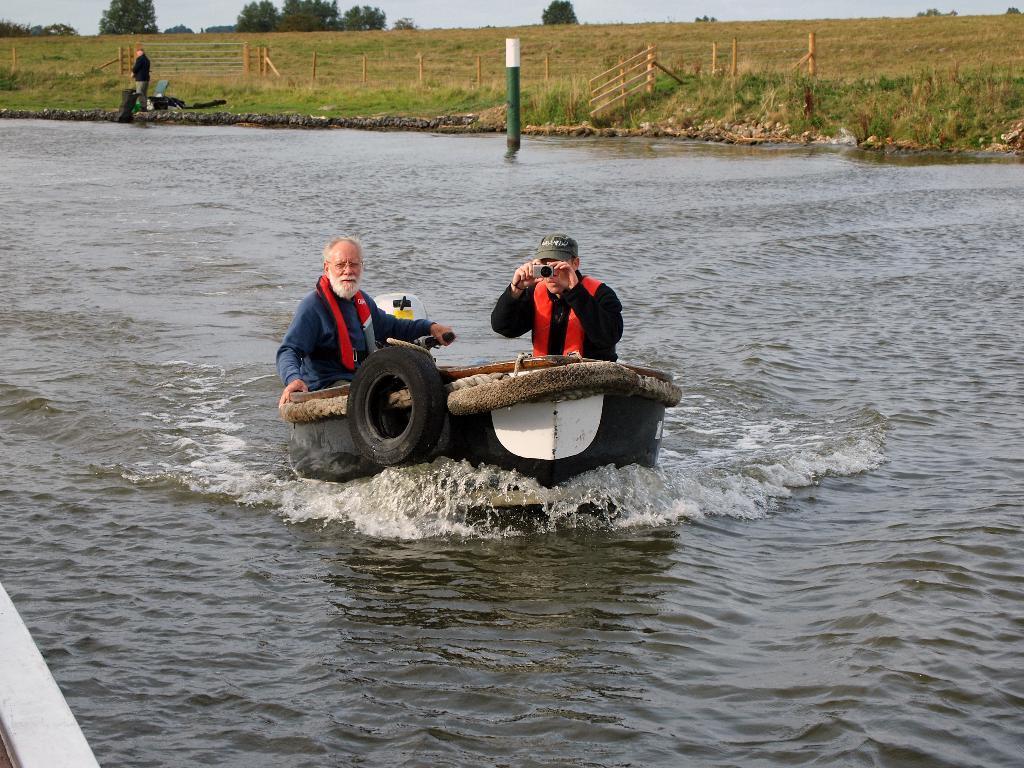Describe this image in one or two sentences. In this image there are two people sitting on the boat, which is on the river, one of them is holding an object. In the background there is a person standing on the surface of the grass and there are a few objects, a wooden fence, trees and the sky. 